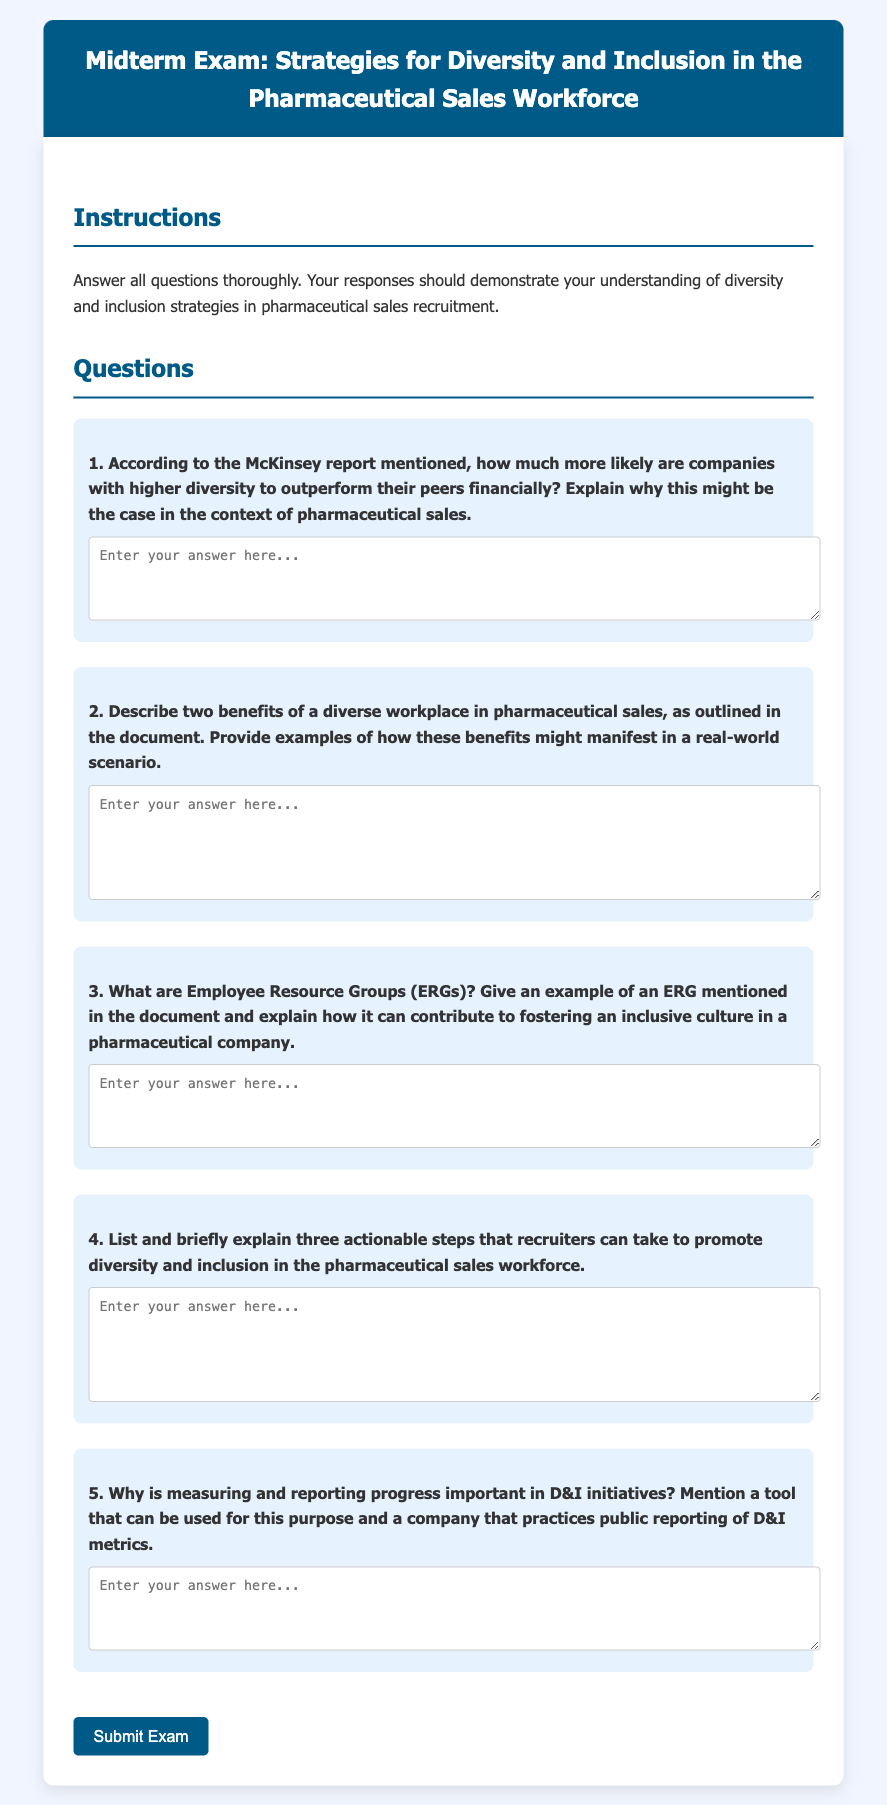1. What is the title of the midterm exam? The title of the midterm exam is found at the top of the document and indicates its focus on diversity and inclusion in the pharmaceutical sales workforce.
Answer: Strategies for Diversity and Inclusion in the Pharmaceutical Sales Workforce 2. According to the instructions, how many questions must be answered? The instructions specify that all questions must be answered thoroughly, indicating there are multiple questions presented in the document.
Answer: All questions 3. What is one example of an Employee Resource Group (ERG) mentioned in the document? The document asks for an example of an ERG, suggesting that specific ERGs are listed within it.
Answer: [Specific example not provided in data] 4. How many actionable steps are recruiters asked to explain to promote diversity? The question prompts the respondents to list a specific number of steps that recruiters can take, implying a focused response.
Answer: Three 5. What is one tool mentioned that can be used for measuring and reporting progress in D&I initiatives? The document emphasizes the importance of tools in measuring progress, indicating that examples are provided for readers to identify.
Answer: [Specific tool not provided in data] 6. What benefit of diversity in the workplace is discussed in the context of pharmaceutical sales? This question refers to benefits stated in the document, indicating opportunities for respondents to cite specific advantages of diversity.
Answer: [Benefit not provided in data] 7. Why is measuring progress in D&I initiatives considered important? This question is designed to elicit a deeper understanding of why tracking D&I is crucial, suggesting that reasoning is required from the document’s content.
Answer: [Reason not provided in data] 8. What is the color of the header background in the document? The color of the header is described in the document's styling specifications, potentially serving as a visual detail for readers.
Answer: #005a87 